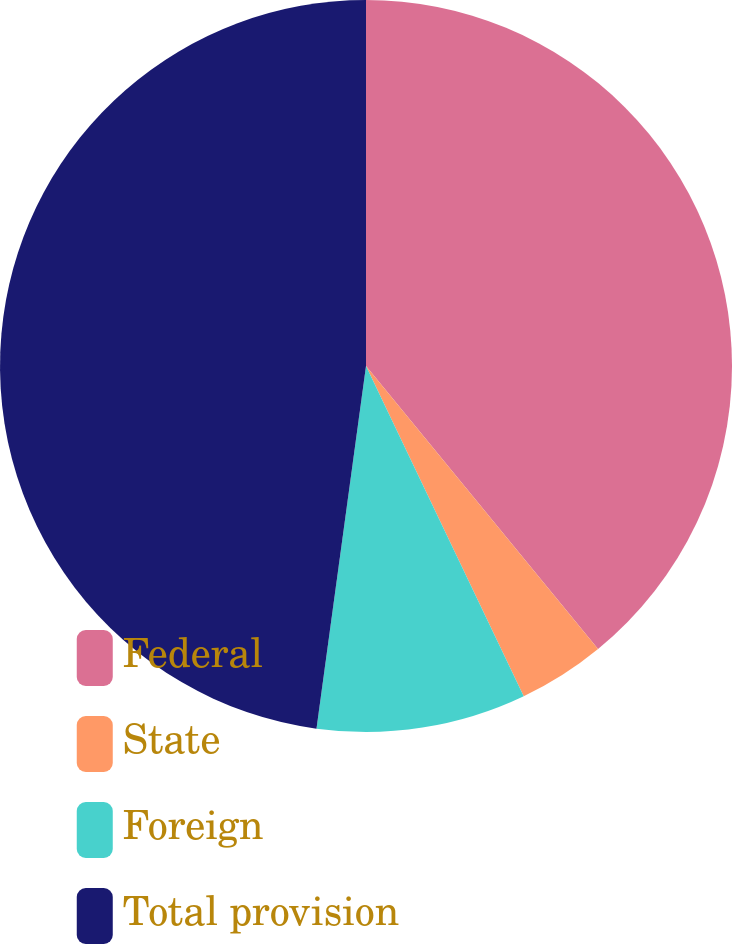<chart> <loc_0><loc_0><loc_500><loc_500><pie_chart><fcel>Federal<fcel>State<fcel>Foreign<fcel>Total provision<nl><fcel>39.07%<fcel>3.84%<fcel>9.25%<fcel>47.84%<nl></chart> 